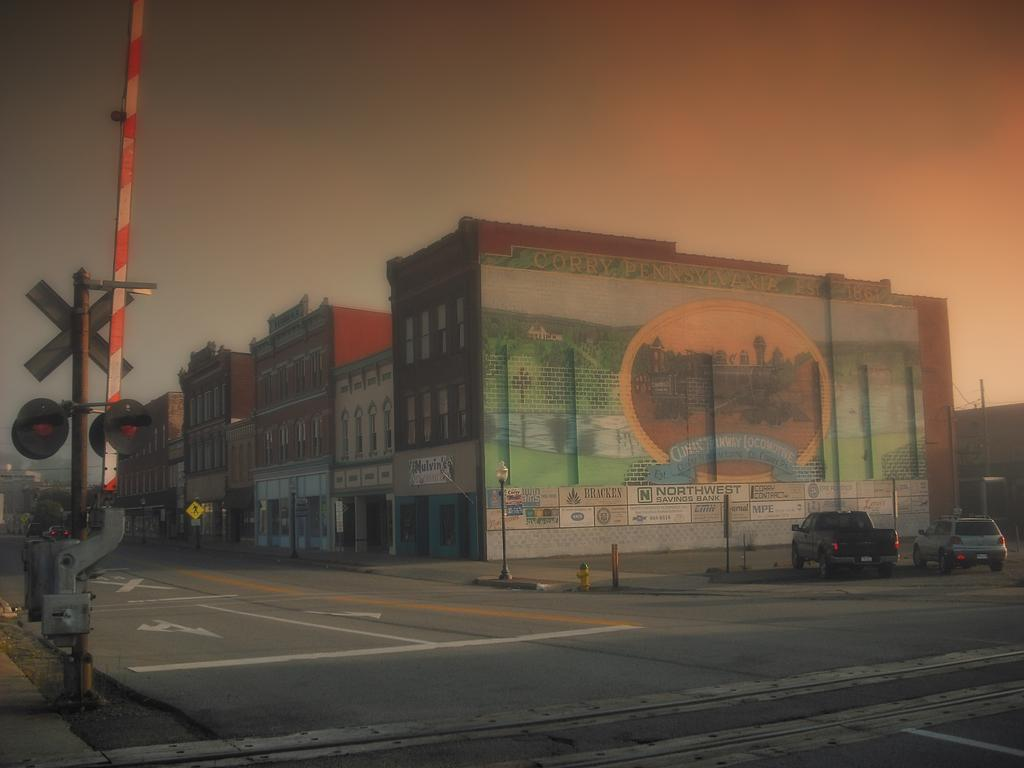What type of structures can be seen in the image? There are buildings in the image. What else can be seen in the image besides the buildings? There are poles and a road visible in the image. What is happening on the road in the image? Cars are visible on the road. What can be seen in the background of the image? There is sky visible in the background of the image. Where is the table located in the image? There is no table present in the image. What type of play is happening in the image? There is no play or any indication of play in the image. 